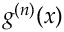Convert formula to latex. <formula><loc_0><loc_0><loc_500><loc_500>g ^ { ( n ) } ( x )</formula> 